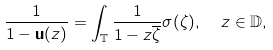<formula> <loc_0><loc_0><loc_500><loc_500>\frac { 1 } { 1 - { \mathbf u } ( z ) } = \int _ { \mathbb { T } } \frac { 1 } { 1 - z \overline { \zeta } } \sigma ( \zeta ) , \ \ z \in \mathbb { D } ,</formula> 